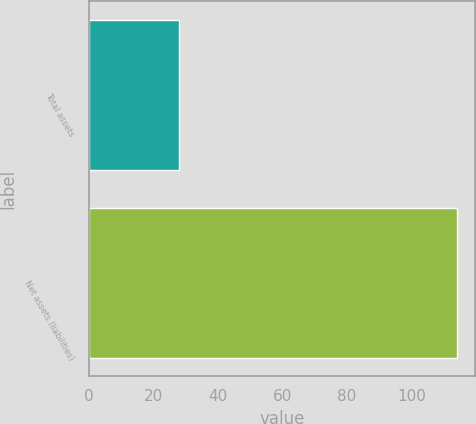Convert chart. <chart><loc_0><loc_0><loc_500><loc_500><bar_chart><fcel>Total assets<fcel>Net assets (liabilities)<nl><fcel>28<fcel>114<nl></chart> 